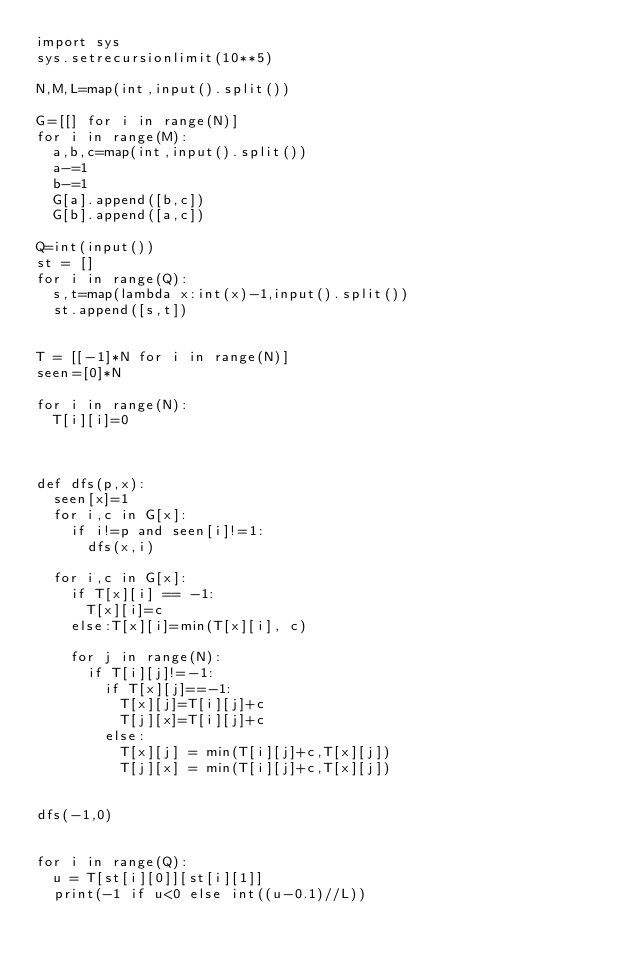<code> <loc_0><loc_0><loc_500><loc_500><_Python_>import sys
sys.setrecursionlimit(10**5)

N,M,L=map(int,input().split())

G=[[] for i in range(N)]
for i in range(M):
	a,b,c=map(int,input().split())
	a-=1
	b-=1
	G[a].append([b,c])
	G[b].append([a,c])

Q=int(input())
st = []
for i in range(Q):
	s,t=map(lambda x:int(x)-1,input().split())
	st.append([s,t])


T = [[-1]*N for i in range(N)]
seen=[0]*N

for i in range(N):
	T[i][i]=0



def dfs(p,x):
	seen[x]=1
	for i,c in G[x]:
		if i!=p and seen[i]!=1:
			dfs(x,i)
	
	for i,c in G[x]:
		if T[x][i] == -1:
			T[x][i]=c
		else:T[x][i]=min(T[x][i], c)
		
		for j in range(N):
			if T[i][j]!=-1:
				if T[x][j]==-1:
					T[x][j]=T[i][j]+c
					T[j][x]=T[i][j]+c
				else:
					T[x][j] = min(T[i][j]+c,T[x][j])
					T[j][x] = min(T[i][j]+c,T[x][j])


dfs(-1,0)


for i in range(Q):
	u = T[st[i][0]][st[i][1]]
	print(-1 if u<0 else int((u-0.1)//L))
</code> 